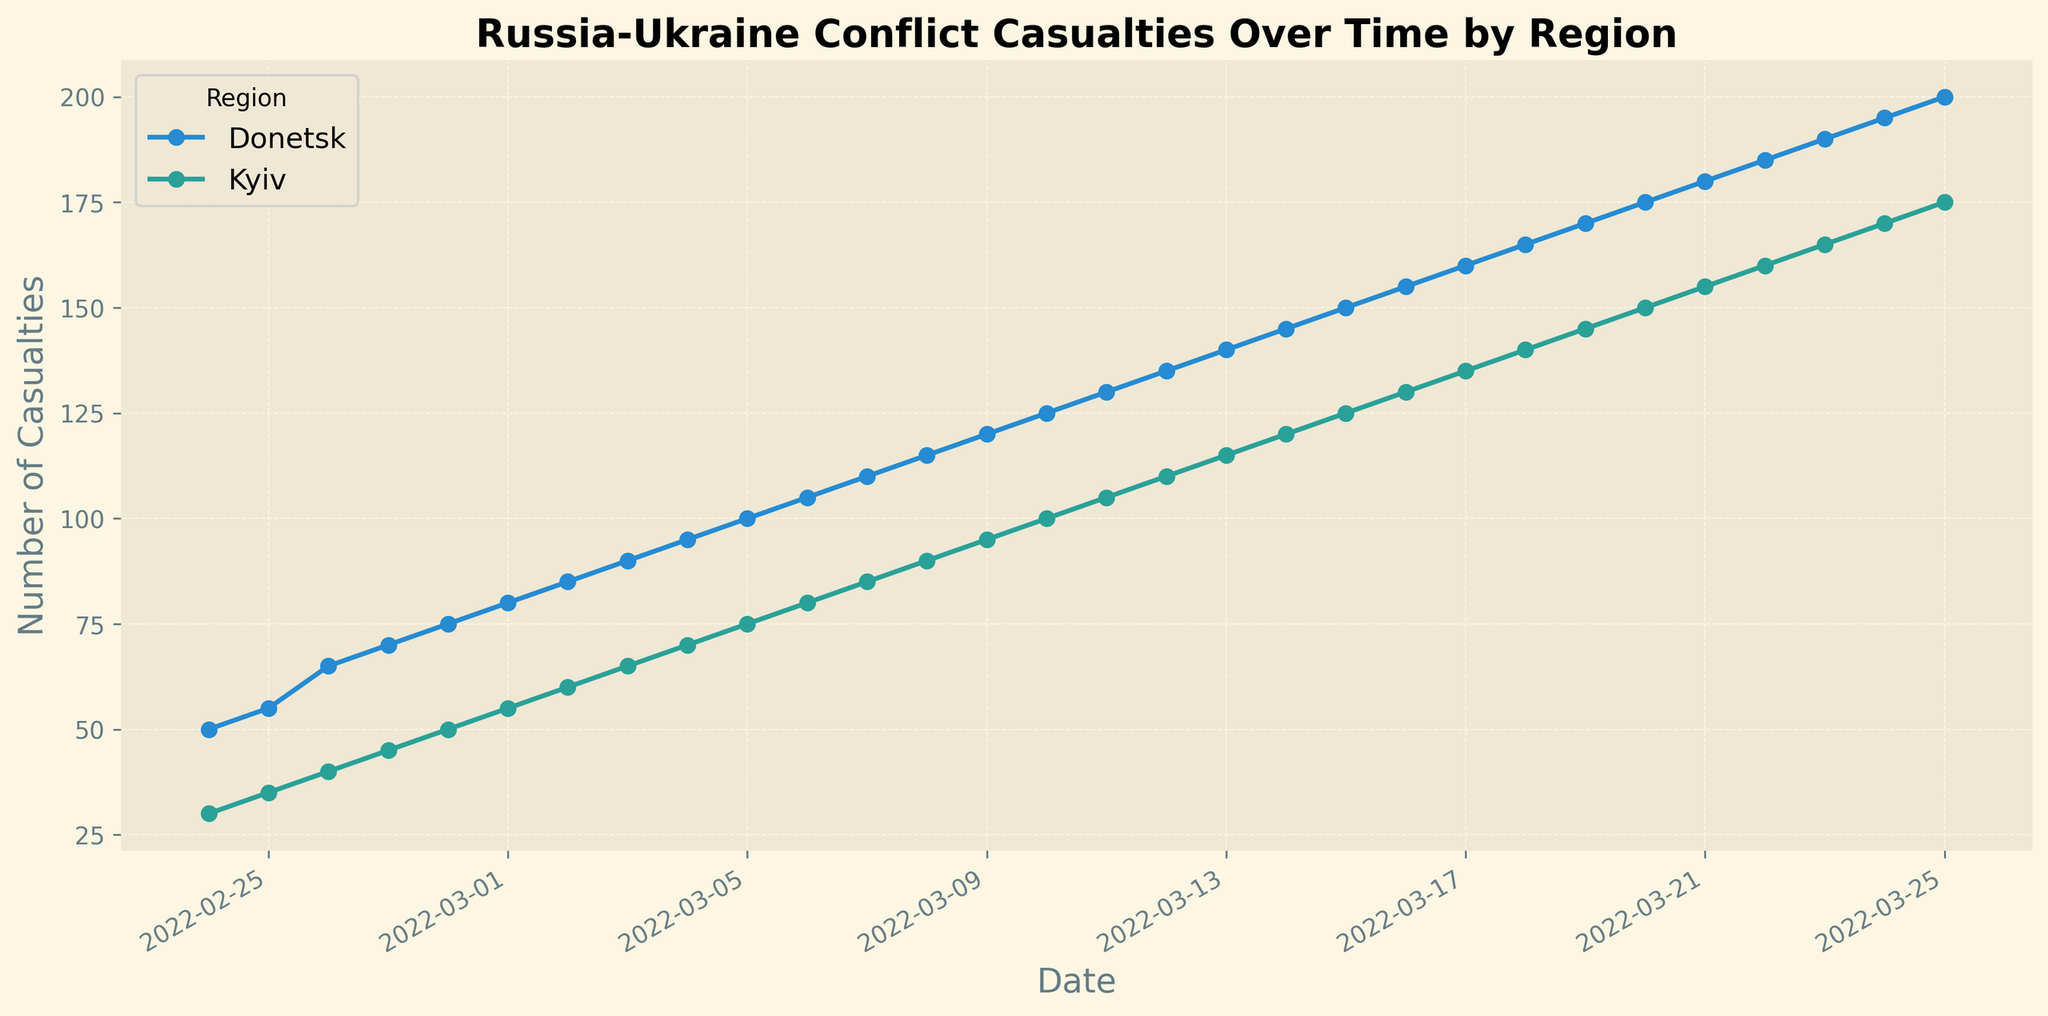What's the trend of casualties in Kyiv over the given time period? To determine the trend in Kyiv, observe the Kyiv line on the graph from the start date to the end date. The line starts at 30 on 2022-02-24 and steadily increases day by day until it reaches 175 on 2022-03-25. Therefore, the trend is a consistent increase in casualties
Answer: Consistent increase Which region had more casualties on 2022-03-01, Kyiv or Donetsk? Locate the data points on 2022-03-01 for both Kyiv and Donetsk lines. Kyiv has 55 casualties and Donetsk has 80 casualties. Since 80 is greater than 55, Donetsk had more casualties on that date
Answer: Donetsk What is the combined total of casualties for both regions on 2022-02-24? Look at the values for Kyiv and Donetsk on 2022-02-24. Kyiv has 30 and Donetsk has 50. Add these values together: 30 + 50 = 80
Answer: 80 Which region shows a steeper increase in casualties from 2022-02-24 to 2022-03-25? To find this, compare the slopes of the lines representing Kyiv and Donetsk between these dates. Both lines increase steadily, but Donetsk's increase is larger (from 50 to 200 = 150 increase) compared to Kyiv (from 30 to 175 = 145 increase). The additional data points show that Donetsk increases at a slightly steeper rate throughout the period
Answer: Donetsk On which date did Kyiv and Donetsk have equal number of casualties? Looking closely at the graph, there is no point where the two lines intersect or have equal values. Kyiv and Donetsk do not have equal casualties on any date shown
Answer: No date What is the difference in casualties between Kyiv and Donetsk on 2022-03-20? Find the values for 2022-03-20 for both regions. Kyiv has 150 casualties and Donetsk has 175 casualties. The difference is 175 - 150 = 25
Answer: 25 Calculate the average daily increase in casualties for Kyiv between 2022-02-24 and 2022-03-25. First, determine the total increase over this period: 175 - 30 = 145. Count the number of days between 2022-02-24 and 2022-03-25, which is 30 days. The average daily increase is 145 / 30 ≈ 4.83 casualties
Answer: 4.83 In which range of dates did Donetsk see a rise from 100 to 150 casualties? Observe the points on the Donetsk line. Donetsk goes from 100 casualties on 2022-03-05 to 150 casualties on 2022-03-15. The range of dates is 2022-03-05 to 2022-03-15
Answer: 2022-03-05 to 2022-03-15 